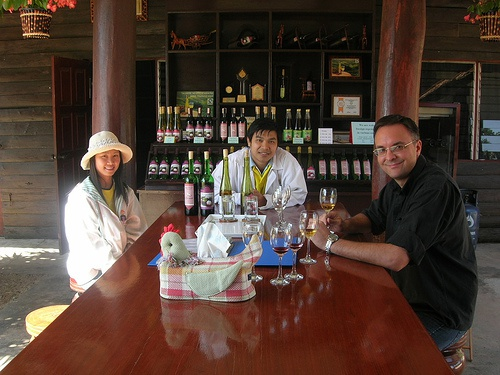Describe the objects in this image and their specific colors. I can see dining table in darkgreen, maroon, gray, darkgray, and brown tones, people in darkgreen, black, brown, and maroon tones, bottle in darkgreen, black, gray, and darkgray tones, people in darkgreen, white, gray, and darkgray tones, and people in darkgreen, darkgray, lavender, black, and gray tones in this image. 